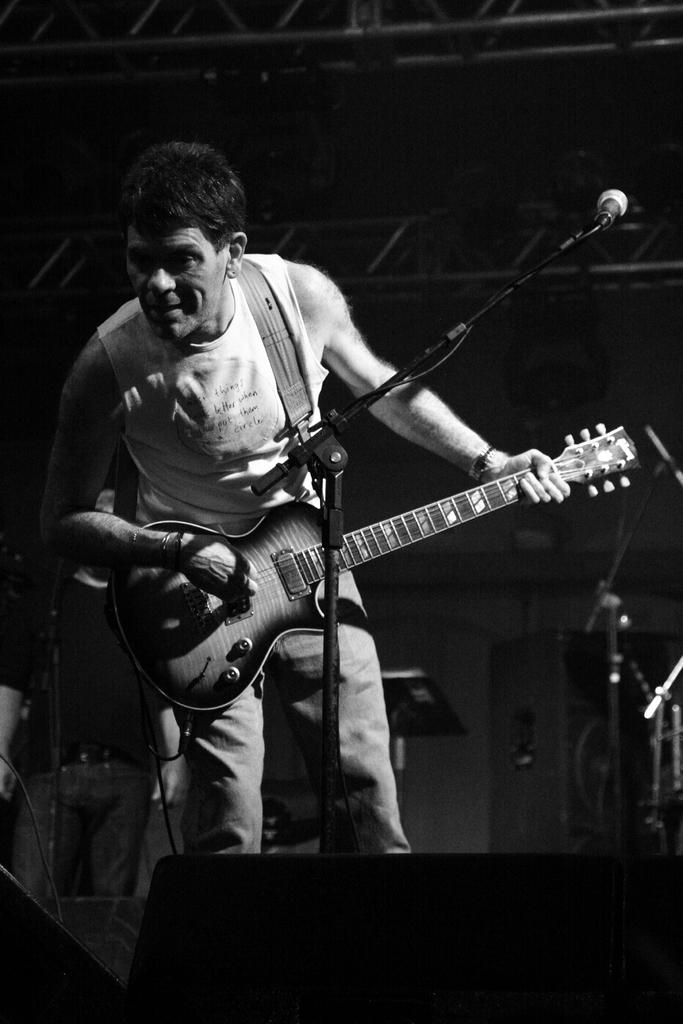What is the main subject of the image? There is a person in the image. What is the person doing in the image? The person is standing in front of a mic. What object is the person holding in the image? The person is holding a guitar. What type of fruit can be seen in the person's hand in the image? There is no fruit present in the image; the person is holding a guitar. 